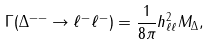Convert formula to latex. <formula><loc_0><loc_0><loc_500><loc_500>\Gamma ( \Delta ^ { - - } \to \ell ^ { - } \ell ^ { - } ) = \frac { 1 } { 8 \pi } h ^ { 2 } _ { \ell \ell } M _ { \Delta } ,</formula> 